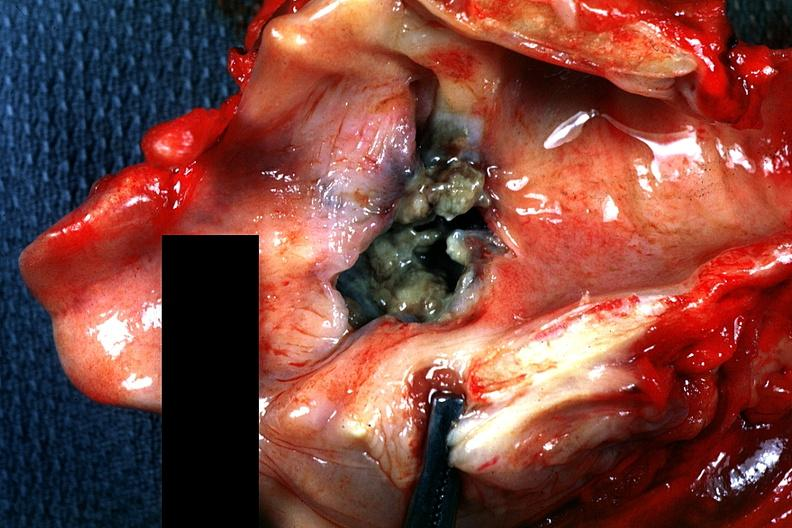what is present?
Answer the question using a single word or phrase. Squamous cell carcinoma 